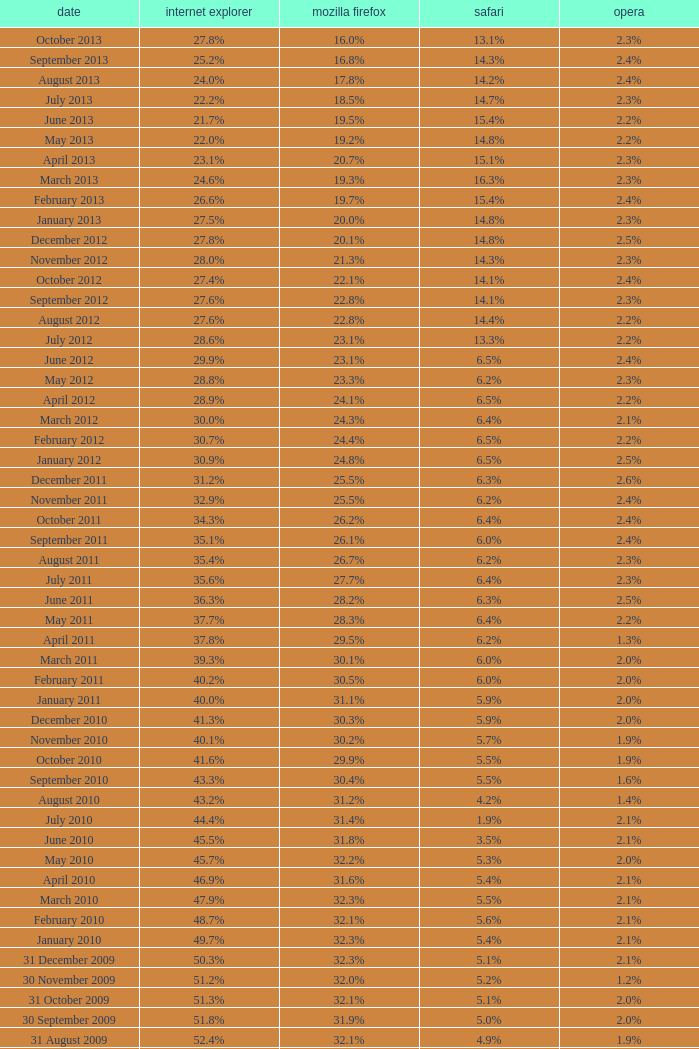What is the firefox value with a 22.0% internet explorer? 19.2%. 